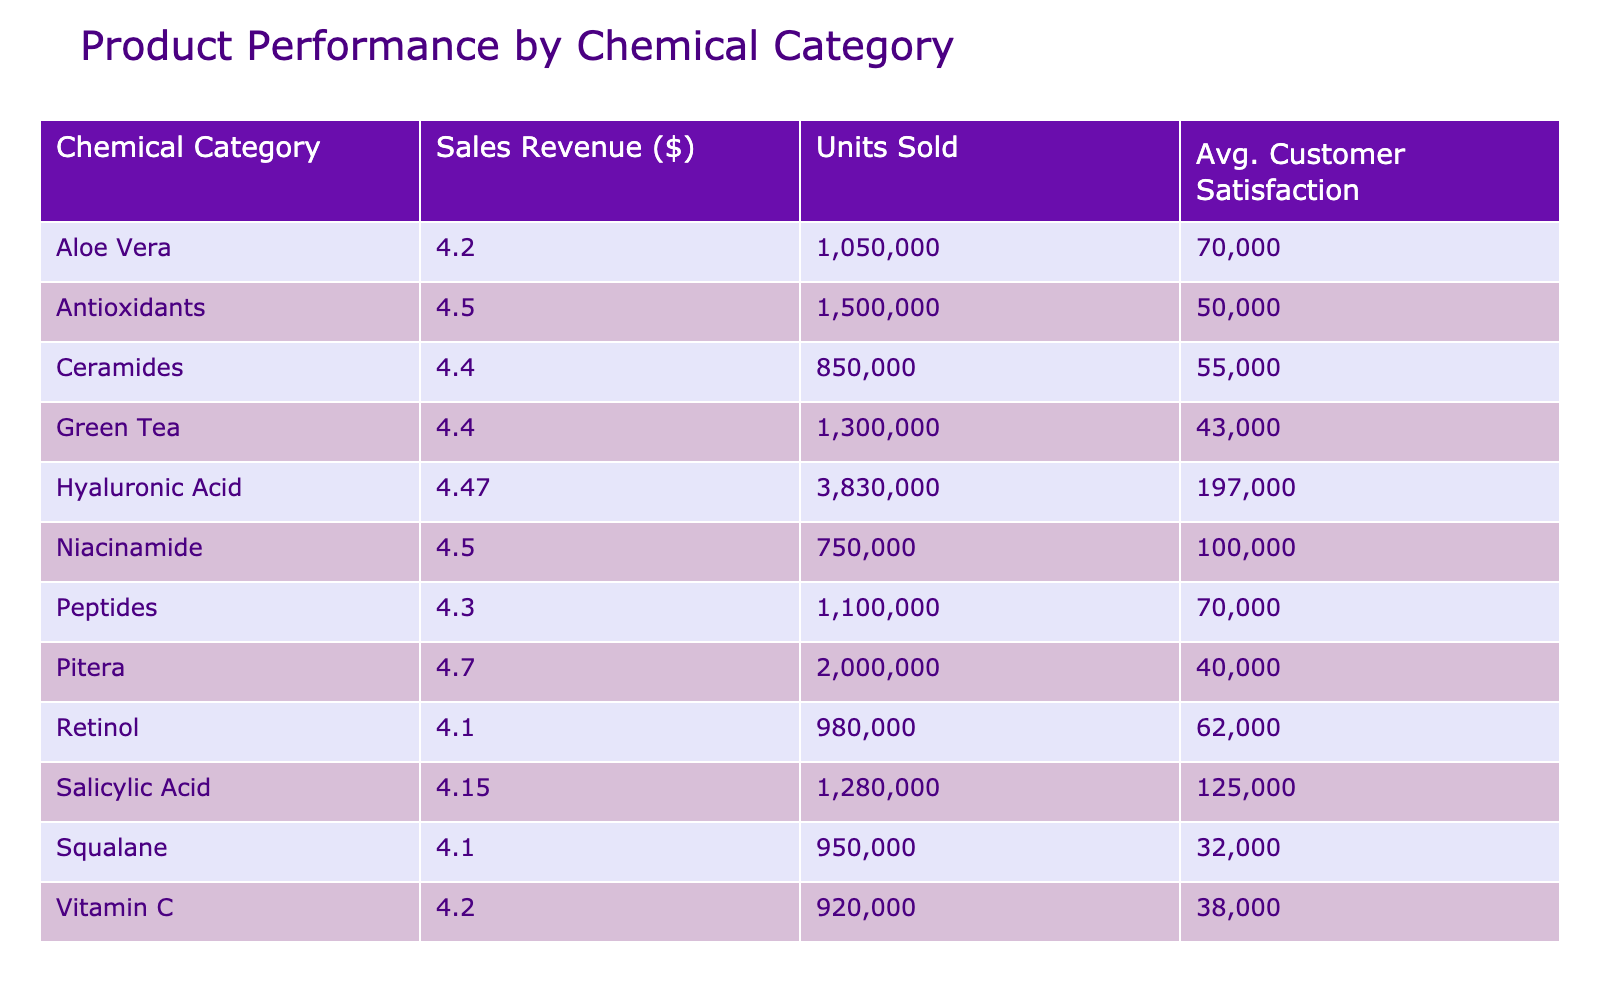What is the total sales revenue for the Retinol category? The Retinol category has a sales revenue of $980,000 according to the table.
Answer: 980000 Which chemical category has the highest average customer satisfaction? The table shows that the Pitera category has the highest average customer satisfaction at 4.7.
Answer: 4.7 What is the total number of units sold across all chemical categories? By adding the units sold from all categories: 85,000 + 62,000 + 70,000 + 55,000 + 100,000 + 40,000 + 45,000 + 60,000 + 38,000 + 50,000 + 80,000 + 43,000 + 32,000 + 52,000 + 70,000 = 832,000 units sold.
Answer: 832000 Is there a correlation between high sales revenue and high customer satisfaction? While high sales revenue doesn't guarantee high customer satisfaction, the table shows that among the higher revenue products, SK-II with $2,000,000 has a customer satisfaction of 4.7, suggesting a positive relationship, but correlation cannot be confirmed solely from the data presented.
Answer: No What is the average sales revenue for the Salicylic Acid category? The Salicylic Acid category includes La Roche-Posay Effaclar with $680,000 and Paula's Choice 2% BHA Liquid with $600,000. To find the average, add the revenues ($680,000 + $600,000 = $1,280,000) and divide by 2, resulting in $640,000.
Answer: 640000 Which region has the highest total sales revenue, and what is that sales figure? The regions and their corresponding sales revenues are North America ($2,500,000), Europe ($2,780,000), and Asia Pacific ($1,800,000). Thus, Europe has the highest total sales revenue at $2,780,000.
Answer: 2780000 What is the difference in average customer satisfaction between the Hyaluronic Acid and Salicylic Acid categories? The average customer satisfaction for the Hyaluronic Acid category is 4.5 (average of Neutrogena and Estée Lauder product values), and for Salicylic Acid, it is 4.15 (average of La Roche-Posay and Paula's Choice). The difference is 4.5 - 4.15 = 0.35.
Answer: 0.35 How many chemical categories have a sales revenue exceeding $1,000,000? The categories with sales revenue over $1,000,000 are Hyaluronic Acid ($3,000,000), Retinol ($980,000), Peptides ($1,100,000), and Pitera ($2,000,000). Thus, there are 3 categories exceeding $1,000,000.
Answer: 3 Is it true that all products in the Asia Pacific region have an average customer satisfaction above 4.5? Looking at the Asia Pacific products, SK-II has a customer satisfaction of 4.7, and Laneige has 4.6, which confirms that all listed products have a customer satisfaction above 4.5.
Answer: Yes 